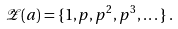Convert formula to latex. <formula><loc_0><loc_0><loc_500><loc_500>\mathcal { Z } ( a ) = \{ 1 , p , p ^ { 2 } , p ^ { 3 } , \dots \} \, .</formula> 